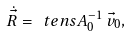Convert formula to latex. <formula><loc_0><loc_0><loc_500><loc_500>\dot { \vec { R } } = \ t e n s { A } ^ { - 1 } _ { 0 } \, \vec { v } _ { 0 } ,</formula> 